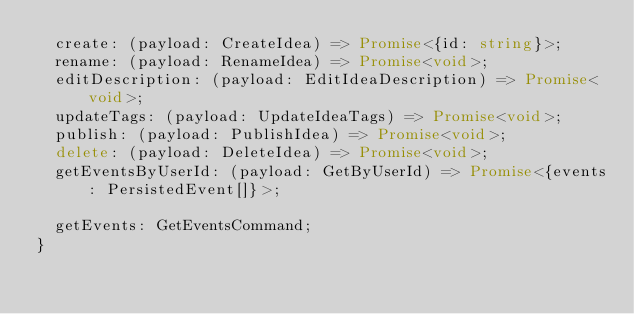Convert code to text. <code><loc_0><loc_0><loc_500><loc_500><_TypeScript_>  create: (payload: CreateIdea) => Promise<{id: string}>;
  rename: (payload: RenameIdea) => Promise<void>;
  editDescription: (payload: EditIdeaDescription) => Promise<void>;
  updateTags: (payload: UpdateIdeaTags) => Promise<void>;
  publish: (payload: PublishIdea) => Promise<void>;
  delete: (payload: DeleteIdea) => Promise<void>;
  getEventsByUserId: (payload: GetByUserId) => Promise<{events: PersistedEvent[]}>;

  getEvents: GetEventsCommand;
}
</code> 